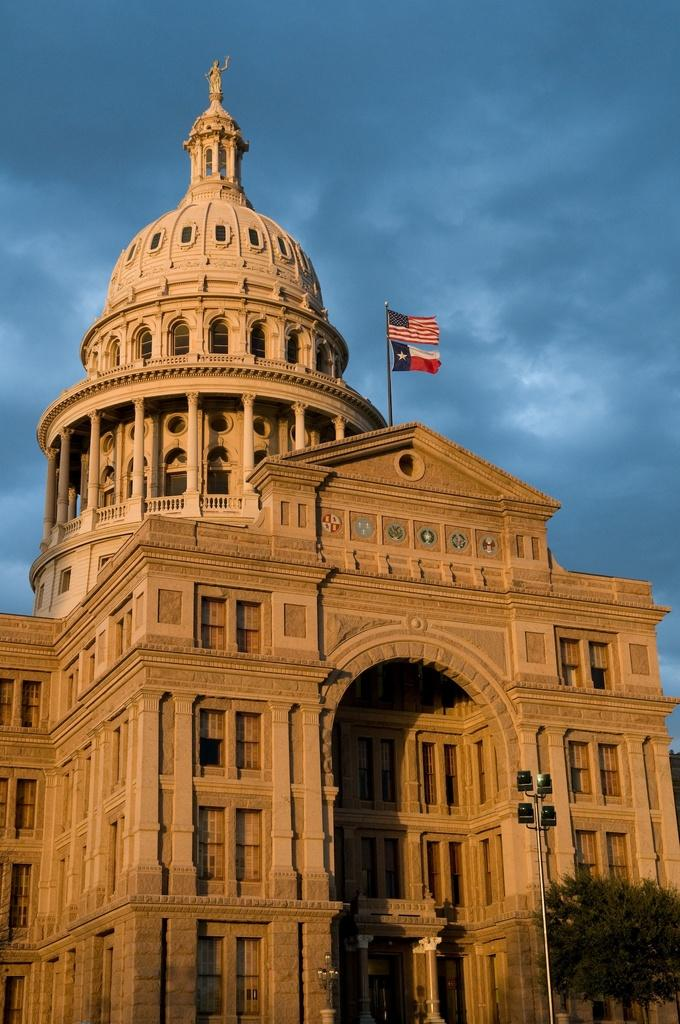What is the main structure featured in the image? There is a Texas state capitol in the image. What can be seen at the top of the image? There are two flags at the top side of the image. What type of natural element is present in the image? There is a tree in the image. What architectural feature can be seen at the bottom side of the image? There is a traffic pole at the bottom side of the image. What type of cloth is draped over the tree in the image? There is no cloth draped over the tree in the image; only the tree itself is visible. 